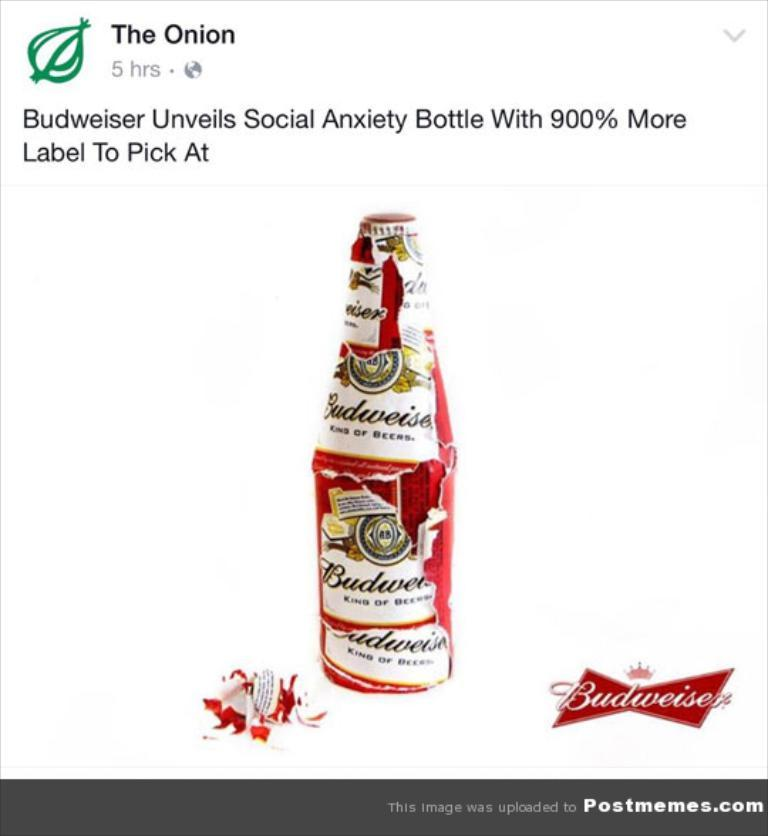What is the main subject of the image? The main subject of the image is a picture of a bottle. What other elements are present in the image besides the bottle? There is text with a logo at the top and bottom of the image. How does the wind affect the flame in the image? There is no wind or flame present in the image; it only features a picture of a bottle and text with logos. 